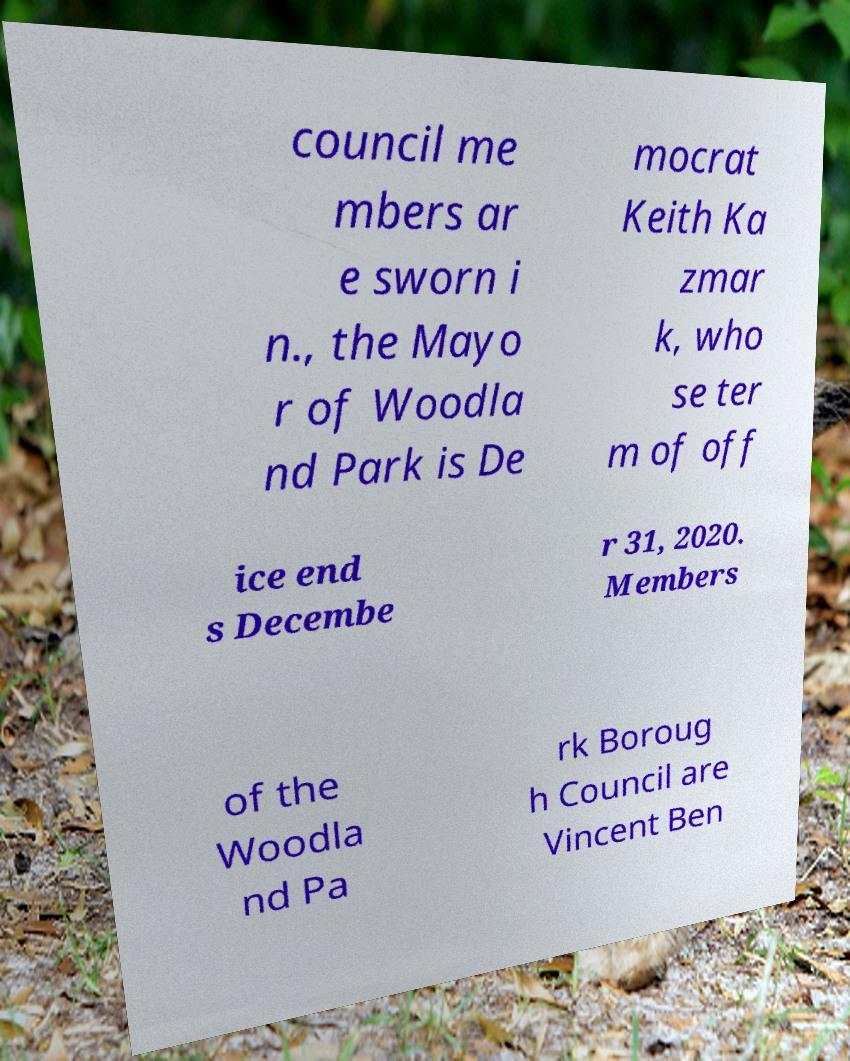I need the written content from this picture converted into text. Can you do that? council me mbers ar e sworn i n., the Mayo r of Woodla nd Park is De mocrat Keith Ka zmar k, who se ter m of off ice end s Decembe r 31, 2020. Members of the Woodla nd Pa rk Boroug h Council are Vincent Ben 